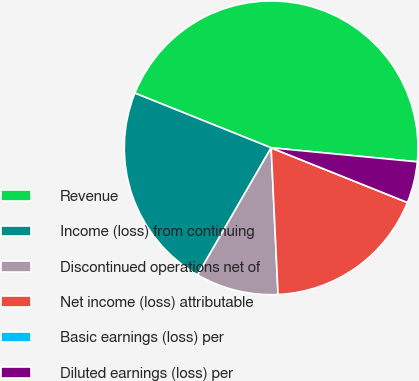Convert chart. <chart><loc_0><loc_0><loc_500><loc_500><pie_chart><fcel>Revenue<fcel>Income (loss) from continuing<fcel>Discontinued operations net of<fcel>Net income (loss) attributable<fcel>Basic earnings (loss) per<fcel>Diluted earnings (loss) per<nl><fcel>45.45%<fcel>22.73%<fcel>9.09%<fcel>18.18%<fcel>0.0%<fcel>4.55%<nl></chart> 